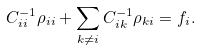<formula> <loc_0><loc_0><loc_500><loc_500>C _ { i i } ^ { - 1 } \rho _ { i i } + \sum _ { k \neq i } C _ { i k } ^ { - 1 } \rho _ { k i } = f _ { i } .</formula> 